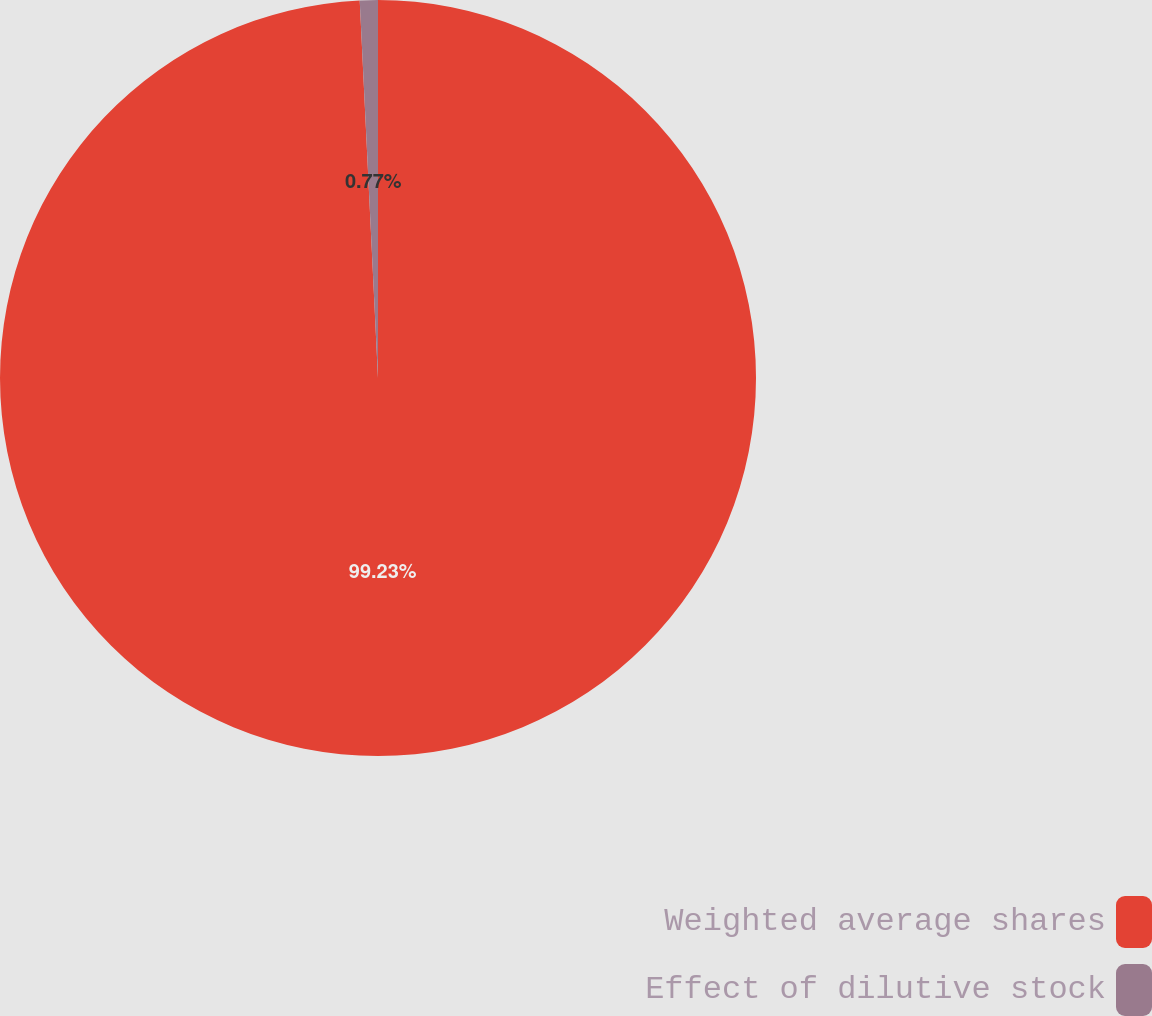Convert chart. <chart><loc_0><loc_0><loc_500><loc_500><pie_chart><fcel>Weighted average shares<fcel>Effect of dilutive stock<nl><fcel>99.23%<fcel>0.77%<nl></chart> 